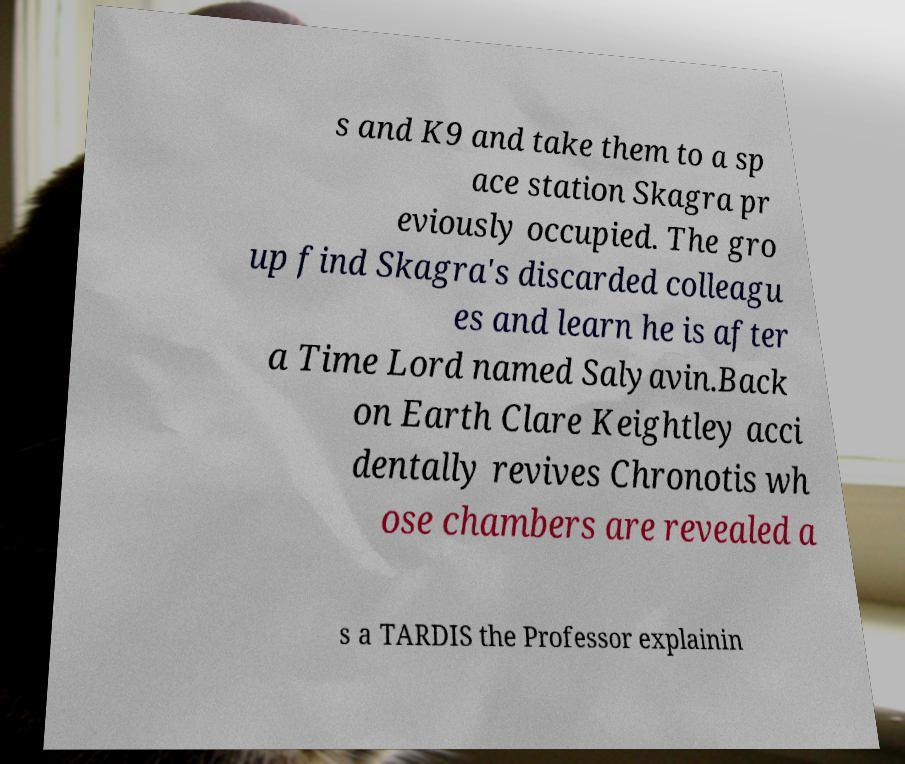Could you assist in decoding the text presented in this image and type it out clearly? s and K9 and take them to a sp ace station Skagra pr eviously occupied. The gro up find Skagra's discarded colleagu es and learn he is after a Time Lord named Salyavin.Back on Earth Clare Keightley acci dentally revives Chronotis wh ose chambers are revealed a s a TARDIS the Professor explainin 